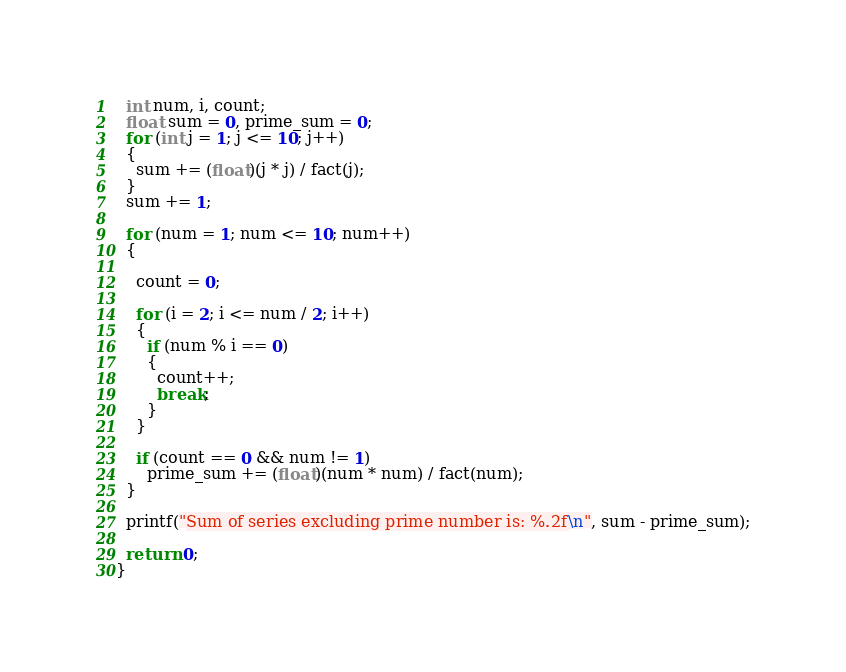Convert code to text. <code><loc_0><loc_0><loc_500><loc_500><_C_>  int num, i, count;
  float sum = 0, prime_sum = 0;
  for (int j = 1; j <= 10; j++)
  {
    sum += (float)(j * j) / fact(j);
  }
  sum += 1;

  for (num = 1; num <= 10; num++)
  {

    count = 0;

    for (i = 2; i <= num / 2; i++)
    {
      if (num % i == 0)
      {
        count++;
        break;
      }
    }

    if (count == 0 && num != 1)
      prime_sum += (float)(num * num) / fact(num);
  }

  printf("Sum of series excluding prime number is: %.2f\n", sum - prime_sum);

  return 0;
}
</code> 